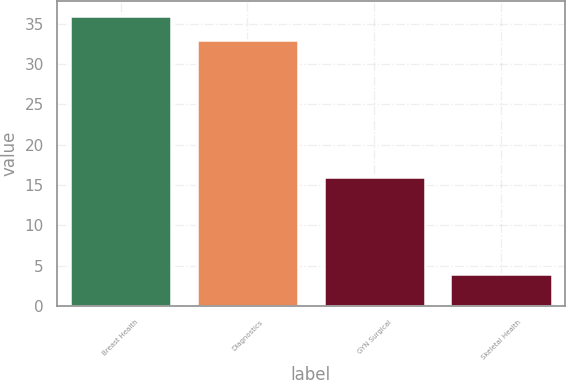<chart> <loc_0><loc_0><loc_500><loc_500><bar_chart><fcel>Breast Health<fcel>Diagnostics<fcel>GYN Surgical<fcel>Skeletal Health<nl><fcel>36<fcel>33<fcel>16<fcel>4<nl></chart> 